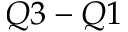<formula> <loc_0><loc_0><loc_500><loc_500>Q 3 - Q 1</formula> 